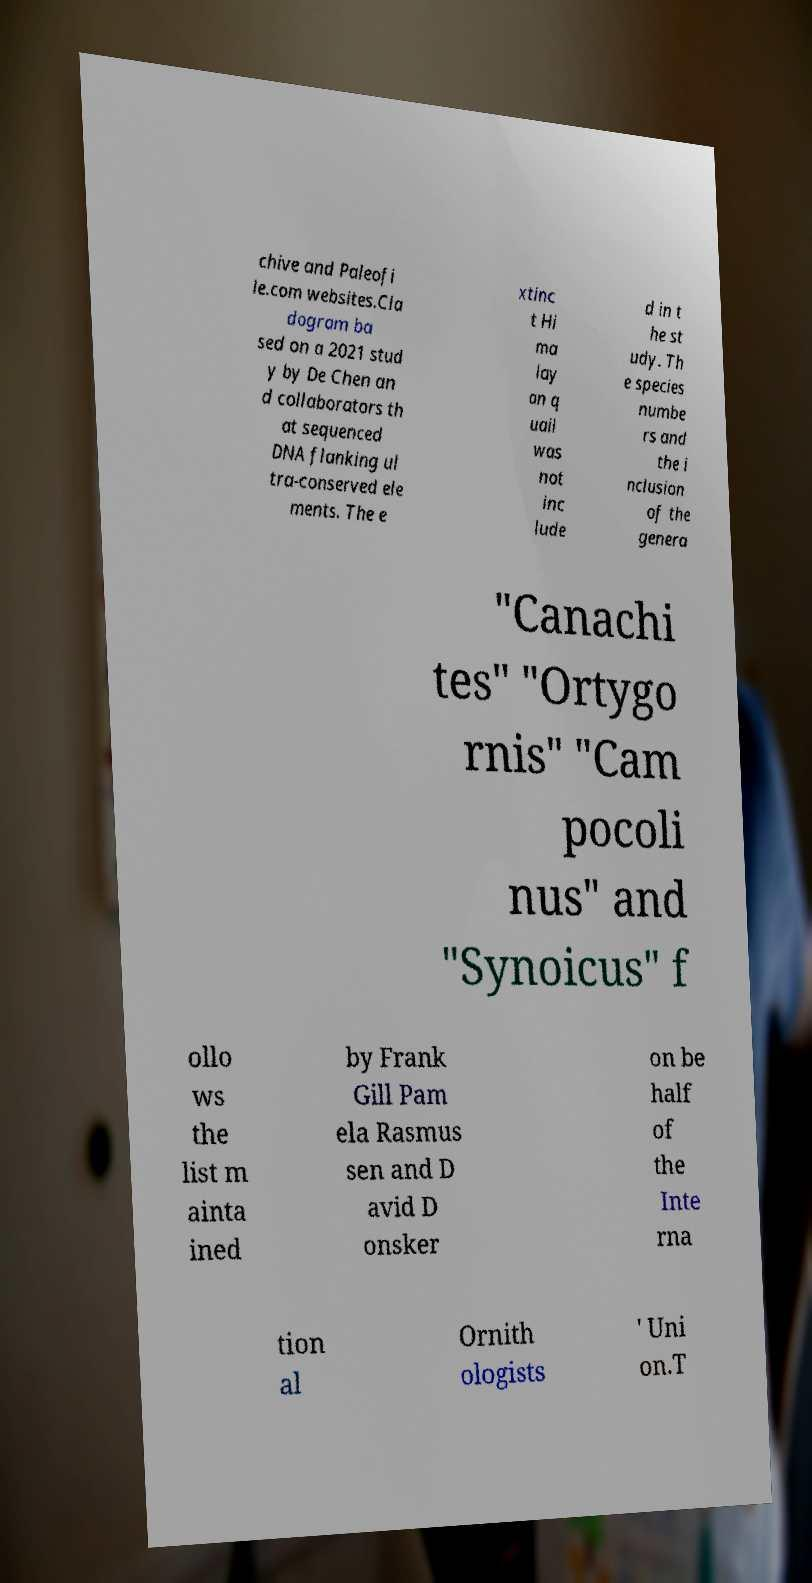What messages or text are displayed in this image? I need them in a readable, typed format. chive and Paleofi le.com websites.Cla dogram ba sed on a 2021 stud y by De Chen an d collaborators th at sequenced DNA flanking ul tra-conserved ele ments. The e xtinc t Hi ma lay an q uail was not inc lude d in t he st udy. Th e species numbe rs and the i nclusion of the genera "Canachi tes" "Ortygo rnis" "Cam pocoli nus" and "Synoicus" f ollo ws the list m ainta ined by Frank Gill Pam ela Rasmus sen and D avid D onsker on be half of the Inte rna tion al Ornith ologists ' Uni on.T 